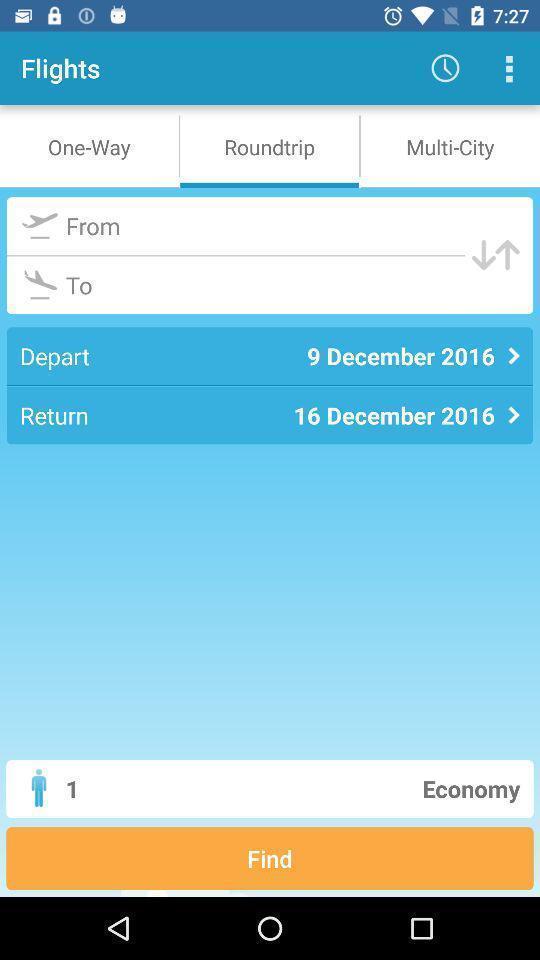What is the overall content of this screenshot? Screen displaying multiple options in an airline booking application. 